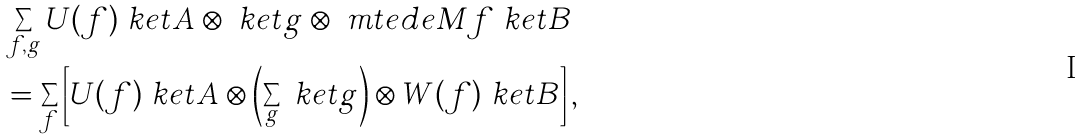Convert formula to latex. <formula><loc_0><loc_0><loc_500><loc_500>& \sum _ { f , g } U ( f ) \ k e t { A } \otimes \ k e t { g } \otimes \ m t e d { e } { M } { f } \ k e t { B } \\ & = \sum _ { f } \left [ U ( f ) \ k e t { A } \otimes \left ( \sum _ { g } \ k e t { g } \right ) \otimes W ( f ) \ k e t { B } \right ] ,</formula> 